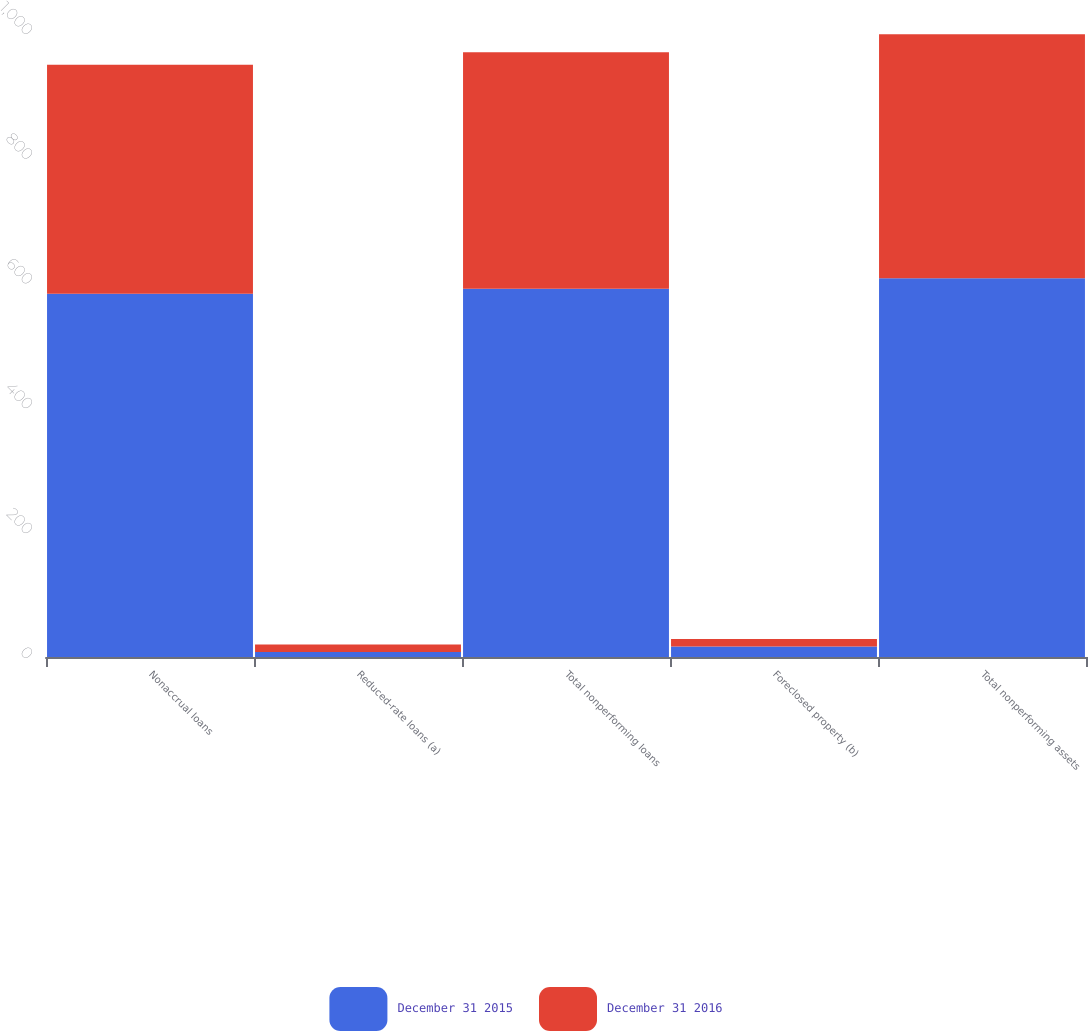Convert chart. <chart><loc_0><loc_0><loc_500><loc_500><stacked_bar_chart><ecel><fcel>Nonaccrual loans<fcel>Reduced-rate loans (a)<fcel>Total nonperforming loans<fcel>Foreclosed property (b)<fcel>Total nonperforming assets<nl><fcel>December 31 2015<fcel>582<fcel>8<fcel>590<fcel>17<fcel>607<nl><fcel>December 31 2016<fcel>367<fcel>12<fcel>379<fcel>12<fcel>391<nl></chart> 